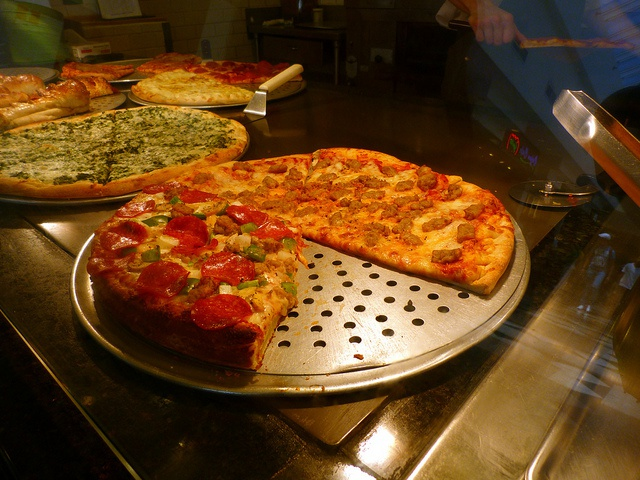Describe the objects in this image and their specific colors. I can see oven in darkgreen, black, olive, and maroon tones, pizza in darkgreen, red, orange, and brown tones, pizza in darkgreen, maroon, black, and brown tones, people in darkgreen, black, navy, maroon, and purple tones, and pizza in darkgreen, olive, and maroon tones in this image. 